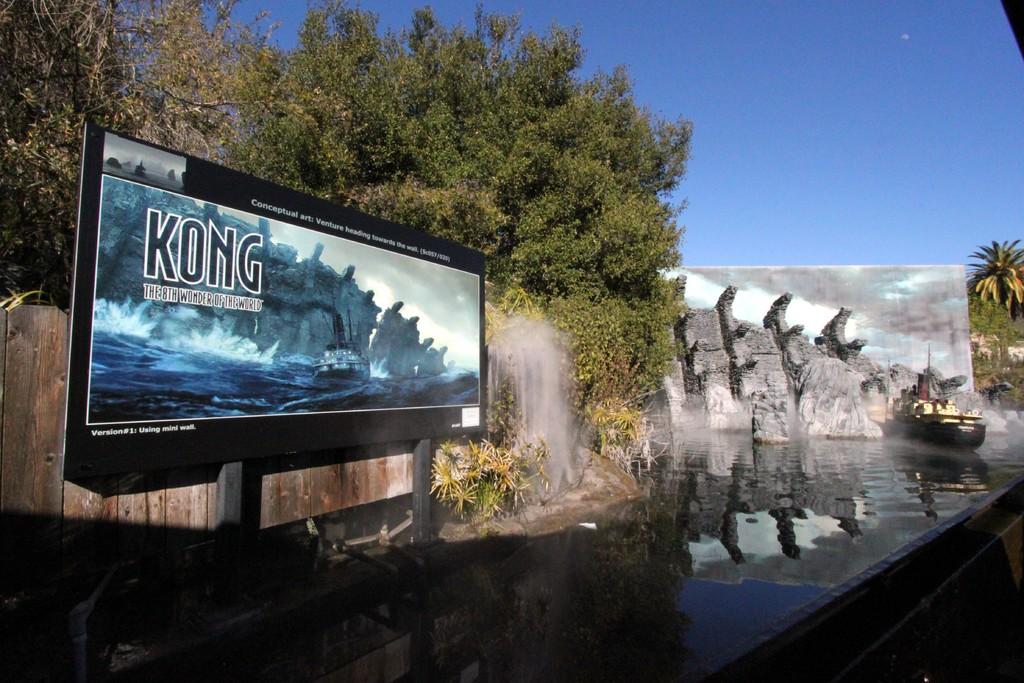What is written on the billboard?
Give a very brief answer. Kong. 